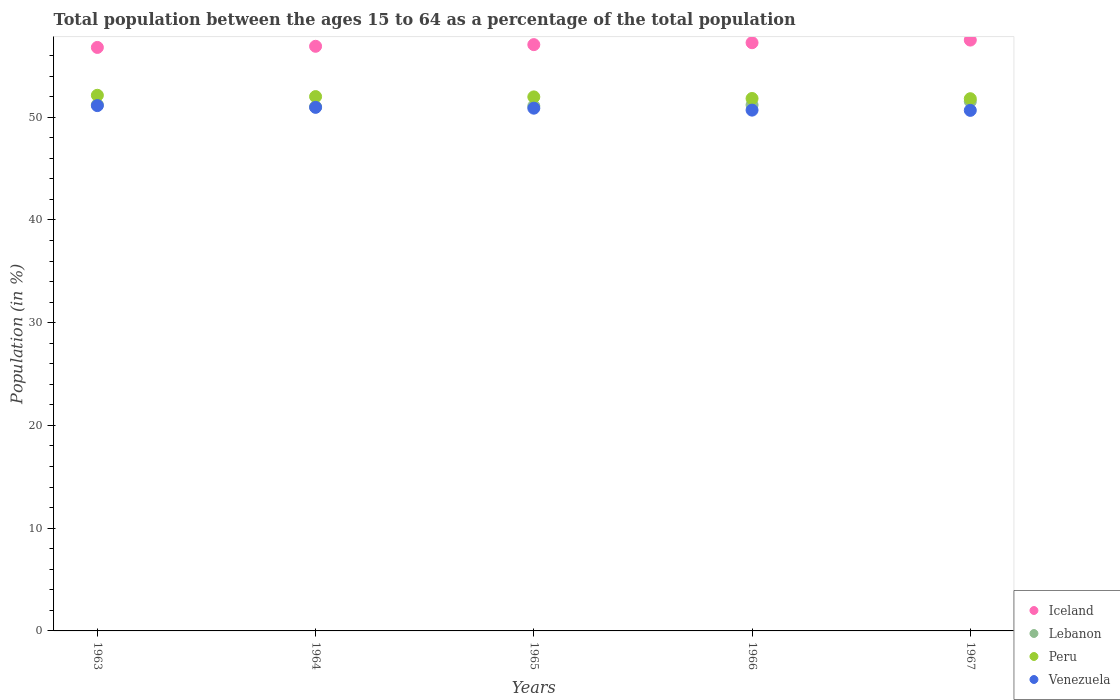Is the number of dotlines equal to the number of legend labels?
Offer a very short reply. Yes. What is the percentage of the population ages 15 to 64 in Lebanon in 1964?
Provide a short and direct response. 51.02. Across all years, what is the maximum percentage of the population ages 15 to 64 in Lebanon?
Give a very brief answer. 51.53. Across all years, what is the minimum percentage of the population ages 15 to 64 in Peru?
Provide a short and direct response. 51.8. In which year was the percentage of the population ages 15 to 64 in Venezuela maximum?
Provide a short and direct response. 1963. In which year was the percentage of the population ages 15 to 64 in Peru minimum?
Keep it short and to the point. 1967. What is the total percentage of the population ages 15 to 64 in Iceland in the graph?
Your answer should be compact. 285.52. What is the difference between the percentage of the population ages 15 to 64 in Lebanon in 1963 and that in 1966?
Your response must be concise. 0.02. What is the difference between the percentage of the population ages 15 to 64 in Iceland in 1966 and the percentage of the population ages 15 to 64 in Peru in 1967?
Your answer should be compact. 5.45. What is the average percentage of the population ages 15 to 64 in Iceland per year?
Keep it short and to the point. 57.1. In the year 1966, what is the difference between the percentage of the population ages 15 to 64 in Lebanon and percentage of the population ages 15 to 64 in Venezuela?
Provide a succinct answer. 0.51. What is the ratio of the percentage of the population ages 15 to 64 in Lebanon in 1965 to that in 1967?
Your response must be concise. 0.99. Is the percentage of the population ages 15 to 64 in Peru in 1963 less than that in 1965?
Your answer should be very brief. No. Is the difference between the percentage of the population ages 15 to 64 in Lebanon in 1965 and 1967 greater than the difference between the percentage of the population ages 15 to 64 in Venezuela in 1965 and 1967?
Offer a very short reply. No. What is the difference between the highest and the second highest percentage of the population ages 15 to 64 in Venezuela?
Your answer should be compact. 0.17. What is the difference between the highest and the lowest percentage of the population ages 15 to 64 in Venezuela?
Your answer should be compact. 0.46. In how many years, is the percentage of the population ages 15 to 64 in Peru greater than the average percentage of the population ages 15 to 64 in Peru taken over all years?
Ensure brevity in your answer.  3. Is the sum of the percentage of the population ages 15 to 64 in Venezuela in 1963 and 1967 greater than the maximum percentage of the population ages 15 to 64 in Peru across all years?
Offer a very short reply. Yes. Is it the case that in every year, the sum of the percentage of the population ages 15 to 64 in Iceland and percentage of the population ages 15 to 64 in Lebanon  is greater than the percentage of the population ages 15 to 64 in Peru?
Your answer should be compact. Yes. Does the percentage of the population ages 15 to 64 in Venezuela monotonically increase over the years?
Your answer should be very brief. No. Is the percentage of the population ages 15 to 64 in Lebanon strictly greater than the percentage of the population ages 15 to 64 in Iceland over the years?
Offer a terse response. No. Is the percentage of the population ages 15 to 64 in Lebanon strictly less than the percentage of the population ages 15 to 64 in Iceland over the years?
Keep it short and to the point. Yes. How many years are there in the graph?
Your answer should be compact. 5. What is the difference between two consecutive major ticks on the Y-axis?
Provide a short and direct response. 10. Does the graph contain grids?
Your answer should be very brief. No. Where does the legend appear in the graph?
Ensure brevity in your answer.  Bottom right. What is the title of the graph?
Your response must be concise. Total population between the ages 15 to 64 as a percentage of the total population. Does "Grenada" appear as one of the legend labels in the graph?
Offer a terse response. No. What is the label or title of the Y-axis?
Ensure brevity in your answer.  Population (in %). What is the Population (in %) in Iceland in 1963?
Offer a very short reply. 56.79. What is the Population (in %) in Lebanon in 1963?
Your answer should be compact. 51.21. What is the Population (in %) of Peru in 1963?
Offer a terse response. 52.13. What is the Population (in %) in Venezuela in 1963?
Your response must be concise. 51.13. What is the Population (in %) in Iceland in 1964?
Offer a terse response. 56.9. What is the Population (in %) of Lebanon in 1964?
Give a very brief answer. 51.02. What is the Population (in %) of Peru in 1964?
Provide a succinct answer. 52.01. What is the Population (in %) in Venezuela in 1964?
Offer a very short reply. 50.96. What is the Population (in %) in Iceland in 1965?
Your answer should be compact. 57.06. What is the Population (in %) of Lebanon in 1965?
Your response must be concise. 51.09. What is the Population (in %) in Peru in 1965?
Give a very brief answer. 51.98. What is the Population (in %) in Venezuela in 1965?
Your answer should be compact. 50.88. What is the Population (in %) in Iceland in 1966?
Offer a terse response. 57.25. What is the Population (in %) in Lebanon in 1966?
Offer a very short reply. 51.2. What is the Population (in %) of Peru in 1966?
Your response must be concise. 51.82. What is the Population (in %) in Venezuela in 1966?
Your answer should be compact. 50.69. What is the Population (in %) of Iceland in 1967?
Provide a succinct answer. 57.51. What is the Population (in %) of Lebanon in 1967?
Offer a terse response. 51.53. What is the Population (in %) of Peru in 1967?
Your answer should be compact. 51.8. What is the Population (in %) in Venezuela in 1967?
Ensure brevity in your answer.  50.67. Across all years, what is the maximum Population (in %) in Iceland?
Offer a terse response. 57.51. Across all years, what is the maximum Population (in %) in Lebanon?
Your answer should be very brief. 51.53. Across all years, what is the maximum Population (in %) of Peru?
Make the answer very short. 52.13. Across all years, what is the maximum Population (in %) in Venezuela?
Give a very brief answer. 51.13. Across all years, what is the minimum Population (in %) of Iceland?
Make the answer very short. 56.79. Across all years, what is the minimum Population (in %) in Lebanon?
Offer a very short reply. 51.02. Across all years, what is the minimum Population (in %) of Peru?
Offer a very short reply. 51.8. Across all years, what is the minimum Population (in %) of Venezuela?
Keep it short and to the point. 50.67. What is the total Population (in %) of Iceland in the graph?
Offer a terse response. 285.52. What is the total Population (in %) of Lebanon in the graph?
Make the answer very short. 256.05. What is the total Population (in %) in Peru in the graph?
Offer a very short reply. 259.75. What is the total Population (in %) of Venezuela in the graph?
Offer a terse response. 254.33. What is the difference between the Population (in %) in Iceland in 1963 and that in 1964?
Ensure brevity in your answer.  -0.11. What is the difference between the Population (in %) in Lebanon in 1963 and that in 1964?
Keep it short and to the point. 0.2. What is the difference between the Population (in %) in Peru in 1963 and that in 1964?
Your answer should be very brief. 0.13. What is the difference between the Population (in %) of Venezuela in 1963 and that in 1964?
Give a very brief answer. 0.17. What is the difference between the Population (in %) in Iceland in 1963 and that in 1965?
Offer a very short reply. -0.27. What is the difference between the Population (in %) of Lebanon in 1963 and that in 1965?
Provide a succinct answer. 0.12. What is the difference between the Population (in %) in Peru in 1963 and that in 1965?
Your answer should be compact. 0.16. What is the difference between the Population (in %) of Venezuela in 1963 and that in 1965?
Your answer should be compact. 0.25. What is the difference between the Population (in %) in Iceland in 1963 and that in 1966?
Your response must be concise. -0.46. What is the difference between the Population (in %) in Lebanon in 1963 and that in 1966?
Provide a short and direct response. 0.02. What is the difference between the Population (in %) in Peru in 1963 and that in 1966?
Ensure brevity in your answer.  0.31. What is the difference between the Population (in %) in Venezuela in 1963 and that in 1966?
Make the answer very short. 0.44. What is the difference between the Population (in %) of Iceland in 1963 and that in 1967?
Your answer should be very brief. -0.71. What is the difference between the Population (in %) of Lebanon in 1963 and that in 1967?
Make the answer very short. -0.32. What is the difference between the Population (in %) in Peru in 1963 and that in 1967?
Your answer should be compact. 0.33. What is the difference between the Population (in %) in Venezuela in 1963 and that in 1967?
Give a very brief answer. 0.46. What is the difference between the Population (in %) in Iceland in 1964 and that in 1965?
Ensure brevity in your answer.  -0.16. What is the difference between the Population (in %) in Lebanon in 1964 and that in 1965?
Provide a short and direct response. -0.08. What is the difference between the Population (in %) in Peru in 1964 and that in 1965?
Keep it short and to the point. 0.03. What is the difference between the Population (in %) in Venezuela in 1964 and that in 1965?
Keep it short and to the point. 0.08. What is the difference between the Population (in %) of Iceland in 1964 and that in 1966?
Provide a short and direct response. -0.35. What is the difference between the Population (in %) of Lebanon in 1964 and that in 1966?
Your response must be concise. -0.18. What is the difference between the Population (in %) in Peru in 1964 and that in 1966?
Your answer should be very brief. 0.18. What is the difference between the Population (in %) of Venezuela in 1964 and that in 1966?
Ensure brevity in your answer.  0.27. What is the difference between the Population (in %) in Iceland in 1964 and that in 1967?
Provide a short and direct response. -0.6. What is the difference between the Population (in %) in Lebanon in 1964 and that in 1967?
Offer a very short reply. -0.52. What is the difference between the Population (in %) of Peru in 1964 and that in 1967?
Keep it short and to the point. 0.21. What is the difference between the Population (in %) of Venezuela in 1964 and that in 1967?
Give a very brief answer. 0.29. What is the difference between the Population (in %) in Iceland in 1965 and that in 1966?
Keep it short and to the point. -0.19. What is the difference between the Population (in %) of Lebanon in 1965 and that in 1966?
Your answer should be compact. -0.1. What is the difference between the Population (in %) of Peru in 1965 and that in 1966?
Keep it short and to the point. 0.16. What is the difference between the Population (in %) of Venezuela in 1965 and that in 1966?
Provide a succinct answer. 0.19. What is the difference between the Population (in %) in Iceland in 1965 and that in 1967?
Give a very brief answer. -0.44. What is the difference between the Population (in %) of Lebanon in 1965 and that in 1967?
Your answer should be compact. -0.44. What is the difference between the Population (in %) of Peru in 1965 and that in 1967?
Give a very brief answer. 0.18. What is the difference between the Population (in %) of Venezuela in 1965 and that in 1967?
Give a very brief answer. 0.21. What is the difference between the Population (in %) of Iceland in 1966 and that in 1967?
Provide a succinct answer. -0.26. What is the difference between the Population (in %) in Lebanon in 1966 and that in 1967?
Keep it short and to the point. -0.34. What is the difference between the Population (in %) in Peru in 1966 and that in 1967?
Provide a short and direct response. 0.02. What is the difference between the Population (in %) in Venezuela in 1966 and that in 1967?
Your response must be concise. 0.02. What is the difference between the Population (in %) of Iceland in 1963 and the Population (in %) of Lebanon in 1964?
Give a very brief answer. 5.78. What is the difference between the Population (in %) in Iceland in 1963 and the Population (in %) in Peru in 1964?
Make the answer very short. 4.79. What is the difference between the Population (in %) of Iceland in 1963 and the Population (in %) of Venezuela in 1964?
Provide a succinct answer. 5.83. What is the difference between the Population (in %) of Lebanon in 1963 and the Population (in %) of Peru in 1964?
Give a very brief answer. -0.79. What is the difference between the Population (in %) in Lebanon in 1963 and the Population (in %) in Venezuela in 1964?
Your response must be concise. 0.25. What is the difference between the Population (in %) in Peru in 1963 and the Population (in %) in Venezuela in 1964?
Provide a short and direct response. 1.17. What is the difference between the Population (in %) of Iceland in 1963 and the Population (in %) of Lebanon in 1965?
Offer a very short reply. 5.7. What is the difference between the Population (in %) of Iceland in 1963 and the Population (in %) of Peru in 1965?
Provide a short and direct response. 4.81. What is the difference between the Population (in %) in Iceland in 1963 and the Population (in %) in Venezuela in 1965?
Provide a short and direct response. 5.91. What is the difference between the Population (in %) of Lebanon in 1963 and the Population (in %) of Peru in 1965?
Provide a short and direct response. -0.76. What is the difference between the Population (in %) in Lebanon in 1963 and the Population (in %) in Venezuela in 1965?
Your answer should be very brief. 0.34. What is the difference between the Population (in %) of Peru in 1963 and the Population (in %) of Venezuela in 1965?
Provide a short and direct response. 1.26. What is the difference between the Population (in %) of Iceland in 1963 and the Population (in %) of Lebanon in 1966?
Make the answer very short. 5.6. What is the difference between the Population (in %) of Iceland in 1963 and the Population (in %) of Peru in 1966?
Offer a terse response. 4.97. What is the difference between the Population (in %) in Iceland in 1963 and the Population (in %) in Venezuela in 1966?
Offer a terse response. 6.1. What is the difference between the Population (in %) in Lebanon in 1963 and the Population (in %) in Peru in 1966?
Make the answer very short. -0.61. What is the difference between the Population (in %) of Lebanon in 1963 and the Population (in %) of Venezuela in 1966?
Give a very brief answer. 0.52. What is the difference between the Population (in %) in Peru in 1963 and the Population (in %) in Venezuela in 1966?
Give a very brief answer. 1.44. What is the difference between the Population (in %) in Iceland in 1963 and the Population (in %) in Lebanon in 1967?
Provide a short and direct response. 5.26. What is the difference between the Population (in %) in Iceland in 1963 and the Population (in %) in Peru in 1967?
Your answer should be very brief. 4.99. What is the difference between the Population (in %) of Iceland in 1963 and the Population (in %) of Venezuela in 1967?
Keep it short and to the point. 6.13. What is the difference between the Population (in %) in Lebanon in 1963 and the Population (in %) in Peru in 1967?
Your response must be concise. -0.59. What is the difference between the Population (in %) of Lebanon in 1963 and the Population (in %) of Venezuela in 1967?
Offer a very short reply. 0.55. What is the difference between the Population (in %) of Peru in 1963 and the Population (in %) of Venezuela in 1967?
Give a very brief answer. 1.47. What is the difference between the Population (in %) in Iceland in 1964 and the Population (in %) in Lebanon in 1965?
Your response must be concise. 5.81. What is the difference between the Population (in %) in Iceland in 1964 and the Population (in %) in Peru in 1965?
Your answer should be compact. 4.93. What is the difference between the Population (in %) of Iceland in 1964 and the Population (in %) of Venezuela in 1965?
Ensure brevity in your answer.  6.02. What is the difference between the Population (in %) of Lebanon in 1964 and the Population (in %) of Peru in 1965?
Offer a terse response. -0.96. What is the difference between the Population (in %) of Lebanon in 1964 and the Population (in %) of Venezuela in 1965?
Offer a very short reply. 0.14. What is the difference between the Population (in %) in Peru in 1964 and the Population (in %) in Venezuela in 1965?
Your response must be concise. 1.13. What is the difference between the Population (in %) in Iceland in 1964 and the Population (in %) in Lebanon in 1966?
Provide a short and direct response. 5.71. What is the difference between the Population (in %) in Iceland in 1964 and the Population (in %) in Peru in 1966?
Provide a succinct answer. 5.08. What is the difference between the Population (in %) of Iceland in 1964 and the Population (in %) of Venezuela in 1966?
Your answer should be very brief. 6.21. What is the difference between the Population (in %) of Lebanon in 1964 and the Population (in %) of Peru in 1966?
Make the answer very short. -0.81. What is the difference between the Population (in %) in Lebanon in 1964 and the Population (in %) in Venezuela in 1966?
Keep it short and to the point. 0.32. What is the difference between the Population (in %) of Peru in 1964 and the Population (in %) of Venezuela in 1966?
Give a very brief answer. 1.32. What is the difference between the Population (in %) of Iceland in 1964 and the Population (in %) of Lebanon in 1967?
Your answer should be compact. 5.37. What is the difference between the Population (in %) of Iceland in 1964 and the Population (in %) of Peru in 1967?
Keep it short and to the point. 5.1. What is the difference between the Population (in %) in Iceland in 1964 and the Population (in %) in Venezuela in 1967?
Offer a terse response. 6.24. What is the difference between the Population (in %) of Lebanon in 1964 and the Population (in %) of Peru in 1967?
Provide a succinct answer. -0.79. What is the difference between the Population (in %) of Lebanon in 1964 and the Population (in %) of Venezuela in 1967?
Offer a very short reply. 0.35. What is the difference between the Population (in %) of Peru in 1964 and the Population (in %) of Venezuela in 1967?
Your answer should be very brief. 1.34. What is the difference between the Population (in %) in Iceland in 1965 and the Population (in %) in Lebanon in 1966?
Offer a terse response. 5.87. What is the difference between the Population (in %) in Iceland in 1965 and the Population (in %) in Peru in 1966?
Provide a succinct answer. 5.24. What is the difference between the Population (in %) of Iceland in 1965 and the Population (in %) of Venezuela in 1966?
Offer a very short reply. 6.37. What is the difference between the Population (in %) in Lebanon in 1965 and the Population (in %) in Peru in 1966?
Keep it short and to the point. -0.73. What is the difference between the Population (in %) in Lebanon in 1965 and the Population (in %) in Venezuela in 1966?
Provide a short and direct response. 0.4. What is the difference between the Population (in %) of Peru in 1965 and the Population (in %) of Venezuela in 1966?
Ensure brevity in your answer.  1.29. What is the difference between the Population (in %) of Iceland in 1965 and the Population (in %) of Lebanon in 1967?
Offer a very short reply. 5.53. What is the difference between the Population (in %) of Iceland in 1965 and the Population (in %) of Peru in 1967?
Keep it short and to the point. 5.26. What is the difference between the Population (in %) in Iceland in 1965 and the Population (in %) in Venezuela in 1967?
Ensure brevity in your answer.  6.4. What is the difference between the Population (in %) of Lebanon in 1965 and the Population (in %) of Peru in 1967?
Keep it short and to the point. -0.71. What is the difference between the Population (in %) in Lebanon in 1965 and the Population (in %) in Venezuela in 1967?
Give a very brief answer. 0.43. What is the difference between the Population (in %) in Peru in 1965 and the Population (in %) in Venezuela in 1967?
Provide a short and direct response. 1.31. What is the difference between the Population (in %) of Iceland in 1966 and the Population (in %) of Lebanon in 1967?
Provide a short and direct response. 5.72. What is the difference between the Population (in %) in Iceland in 1966 and the Population (in %) in Peru in 1967?
Keep it short and to the point. 5.45. What is the difference between the Population (in %) in Iceland in 1966 and the Population (in %) in Venezuela in 1967?
Give a very brief answer. 6.59. What is the difference between the Population (in %) in Lebanon in 1966 and the Population (in %) in Peru in 1967?
Ensure brevity in your answer.  -0.61. What is the difference between the Population (in %) in Lebanon in 1966 and the Population (in %) in Venezuela in 1967?
Your response must be concise. 0.53. What is the difference between the Population (in %) of Peru in 1966 and the Population (in %) of Venezuela in 1967?
Make the answer very short. 1.16. What is the average Population (in %) of Iceland per year?
Your answer should be very brief. 57.1. What is the average Population (in %) in Lebanon per year?
Keep it short and to the point. 51.21. What is the average Population (in %) of Peru per year?
Make the answer very short. 51.95. What is the average Population (in %) of Venezuela per year?
Make the answer very short. 50.87. In the year 1963, what is the difference between the Population (in %) of Iceland and Population (in %) of Lebanon?
Make the answer very short. 5.58. In the year 1963, what is the difference between the Population (in %) of Iceland and Population (in %) of Peru?
Make the answer very short. 4.66. In the year 1963, what is the difference between the Population (in %) in Iceland and Population (in %) in Venezuela?
Provide a succinct answer. 5.66. In the year 1963, what is the difference between the Population (in %) in Lebanon and Population (in %) in Peru?
Provide a short and direct response. -0.92. In the year 1963, what is the difference between the Population (in %) of Lebanon and Population (in %) of Venezuela?
Keep it short and to the point. 0.08. In the year 1964, what is the difference between the Population (in %) in Iceland and Population (in %) in Lebanon?
Your response must be concise. 5.89. In the year 1964, what is the difference between the Population (in %) in Iceland and Population (in %) in Peru?
Your answer should be very brief. 4.9. In the year 1964, what is the difference between the Population (in %) of Iceland and Population (in %) of Venezuela?
Your answer should be compact. 5.94. In the year 1964, what is the difference between the Population (in %) of Lebanon and Population (in %) of Peru?
Ensure brevity in your answer.  -0.99. In the year 1964, what is the difference between the Population (in %) of Lebanon and Population (in %) of Venezuela?
Keep it short and to the point. 0.05. In the year 1964, what is the difference between the Population (in %) of Peru and Population (in %) of Venezuela?
Provide a short and direct response. 1.05. In the year 1965, what is the difference between the Population (in %) of Iceland and Population (in %) of Lebanon?
Keep it short and to the point. 5.97. In the year 1965, what is the difference between the Population (in %) of Iceland and Population (in %) of Peru?
Your answer should be compact. 5.09. In the year 1965, what is the difference between the Population (in %) in Iceland and Population (in %) in Venezuela?
Give a very brief answer. 6.19. In the year 1965, what is the difference between the Population (in %) in Lebanon and Population (in %) in Peru?
Give a very brief answer. -0.89. In the year 1965, what is the difference between the Population (in %) in Lebanon and Population (in %) in Venezuela?
Ensure brevity in your answer.  0.21. In the year 1965, what is the difference between the Population (in %) in Peru and Population (in %) in Venezuela?
Keep it short and to the point. 1.1. In the year 1966, what is the difference between the Population (in %) of Iceland and Population (in %) of Lebanon?
Make the answer very short. 6.06. In the year 1966, what is the difference between the Population (in %) of Iceland and Population (in %) of Peru?
Ensure brevity in your answer.  5.43. In the year 1966, what is the difference between the Population (in %) of Iceland and Population (in %) of Venezuela?
Offer a terse response. 6.56. In the year 1966, what is the difference between the Population (in %) of Lebanon and Population (in %) of Peru?
Your answer should be compact. -0.63. In the year 1966, what is the difference between the Population (in %) in Lebanon and Population (in %) in Venezuela?
Your answer should be compact. 0.51. In the year 1966, what is the difference between the Population (in %) of Peru and Population (in %) of Venezuela?
Your answer should be compact. 1.13. In the year 1967, what is the difference between the Population (in %) in Iceland and Population (in %) in Lebanon?
Your answer should be compact. 5.97. In the year 1967, what is the difference between the Population (in %) in Iceland and Population (in %) in Peru?
Give a very brief answer. 5.71. In the year 1967, what is the difference between the Population (in %) in Iceland and Population (in %) in Venezuela?
Offer a terse response. 6.84. In the year 1967, what is the difference between the Population (in %) in Lebanon and Population (in %) in Peru?
Ensure brevity in your answer.  -0.27. In the year 1967, what is the difference between the Population (in %) in Lebanon and Population (in %) in Venezuela?
Provide a short and direct response. 0.87. In the year 1967, what is the difference between the Population (in %) in Peru and Population (in %) in Venezuela?
Your response must be concise. 1.13. What is the ratio of the Population (in %) in Lebanon in 1963 to that in 1964?
Your response must be concise. 1. What is the ratio of the Population (in %) in Peru in 1963 to that in 1964?
Your response must be concise. 1. What is the ratio of the Population (in %) of Venezuela in 1963 to that in 1964?
Offer a very short reply. 1. What is the ratio of the Population (in %) in Iceland in 1963 to that in 1965?
Your answer should be very brief. 1. What is the ratio of the Population (in %) of Lebanon in 1963 to that in 1965?
Provide a succinct answer. 1. What is the ratio of the Population (in %) of Peru in 1963 to that in 1965?
Make the answer very short. 1. What is the ratio of the Population (in %) of Venezuela in 1963 to that in 1965?
Give a very brief answer. 1. What is the ratio of the Population (in %) of Iceland in 1963 to that in 1966?
Provide a short and direct response. 0.99. What is the ratio of the Population (in %) in Venezuela in 1963 to that in 1966?
Your answer should be compact. 1.01. What is the ratio of the Population (in %) in Iceland in 1963 to that in 1967?
Offer a terse response. 0.99. What is the ratio of the Population (in %) in Peru in 1963 to that in 1967?
Keep it short and to the point. 1.01. What is the ratio of the Population (in %) of Venezuela in 1963 to that in 1967?
Provide a succinct answer. 1.01. What is the ratio of the Population (in %) of Lebanon in 1964 to that in 1965?
Your answer should be compact. 1. What is the ratio of the Population (in %) in Lebanon in 1964 to that in 1966?
Offer a terse response. 1. What is the ratio of the Population (in %) of Peru in 1964 to that in 1966?
Provide a succinct answer. 1. What is the ratio of the Population (in %) in Venezuela in 1964 to that in 1966?
Your response must be concise. 1.01. What is the ratio of the Population (in %) in Lebanon in 1964 to that in 1967?
Ensure brevity in your answer.  0.99. What is the ratio of the Population (in %) of Peru in 1964 to that in 1967?
Ensure brevity in your answer.  1. What is the ratio of the Population (in %) of Iceland in 1965 to that in 1966?
Provide a short and direct response. 1. What is the ratio of the Population (in %) of Peru in 1965 to that in 1966?
Your answer should be compact. 1. What is the ratio of the Population (in %) of Iceland in 1965 to that in 1967?
Offer a terse response. 0.99. What is the ratio of the Population (in %) in Lebanon in 1965 to that in 1967?
Provide a short and direct response. 0.99. What is the ratio of the Population (in %) of Peru in 1965 to that in 1967?
Ensure brevity in your answer.  1. What is the ratio of the Population (in %) in Iceland in 1966 to that in 1967?
Offer a terse response. 1. What is the ratio of the Population (in %) in Peru in 1966 to that in 1967?
Keep it short and to the point. 1. What is the difference between the highest and the second highest Population (in %) in Iceland?
Give a very brief answer. 0.26. What is the difference between the highest and the second highest Population (in %) in Lebanon?
Your answer should be compact. 0.32. What is the difference between the highest and the second highest Population (in %) in Peru?
Your response must be concise. 0.13. What is the difference between the highest and the second highest Population (in %) in Venezuela?
Your answer should be very brief. 0.17. What is the difference between the highest and the lowest Population (in %) of Iceland?
Provide a succinct answer. 0.71. What is the difference between the highest and the lowest Population (in %) of Lebanon?
Make the answer very short. 0.52. What is the difference between the highest and the lowest Population (in %) of Peru?
Your answer should be very brief. 0.33. What is the difference between the highest and the lowest Population (in %) in Venezuela?
Ensure brevity in your answer.  0.46. 